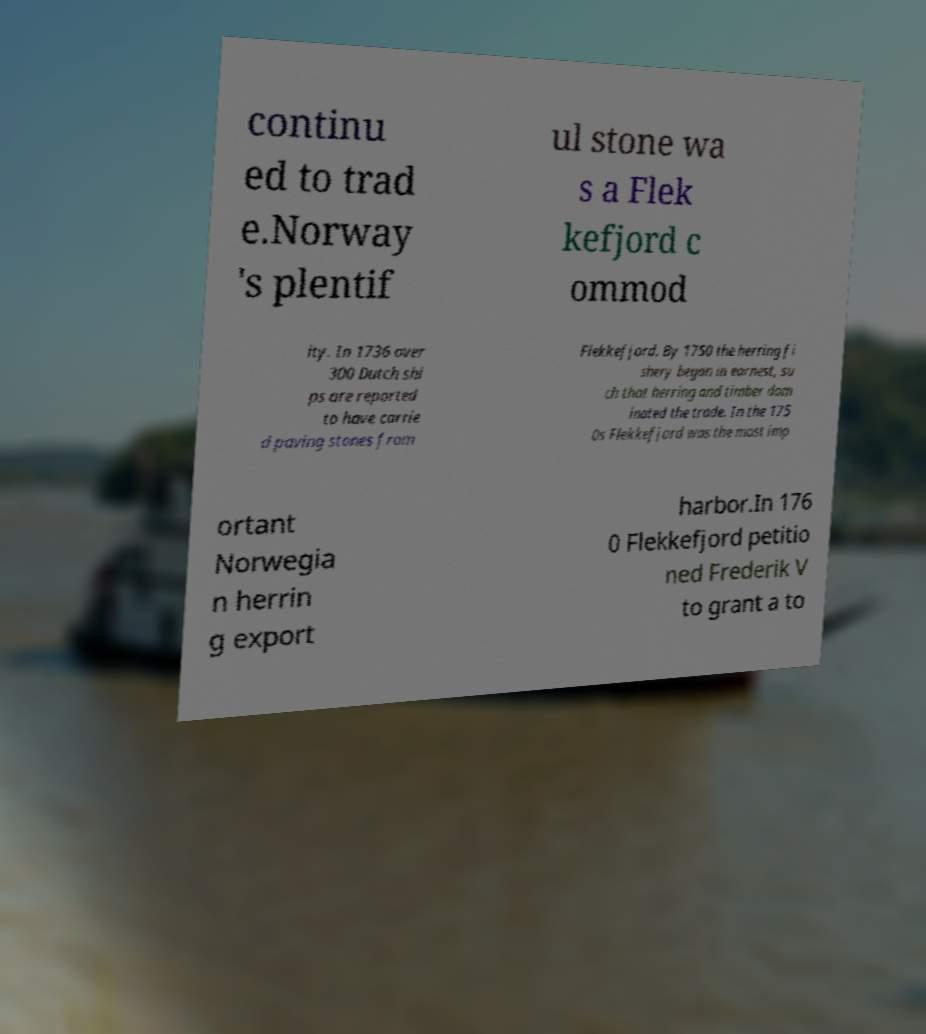There's text embedded in this image that I need extracted. Can you transcribe it verbatim? continu ed to trad e.Norway 's plentif ul stone wa s a Flek kefjord c ommod ity. In 1736 over 300 Dutch shi ps are reported to have carrie d paving stones from Flekkefjord. By 1750 the herring fi shery began in earnest, su ch that herring and timber dom inated the trade. In the 175 0s Flekkefjord was the most imp ortant Norwegia n herrin g export harbor.In 176 0 Flekkefjord petitio ned Frederik V to grant a to 